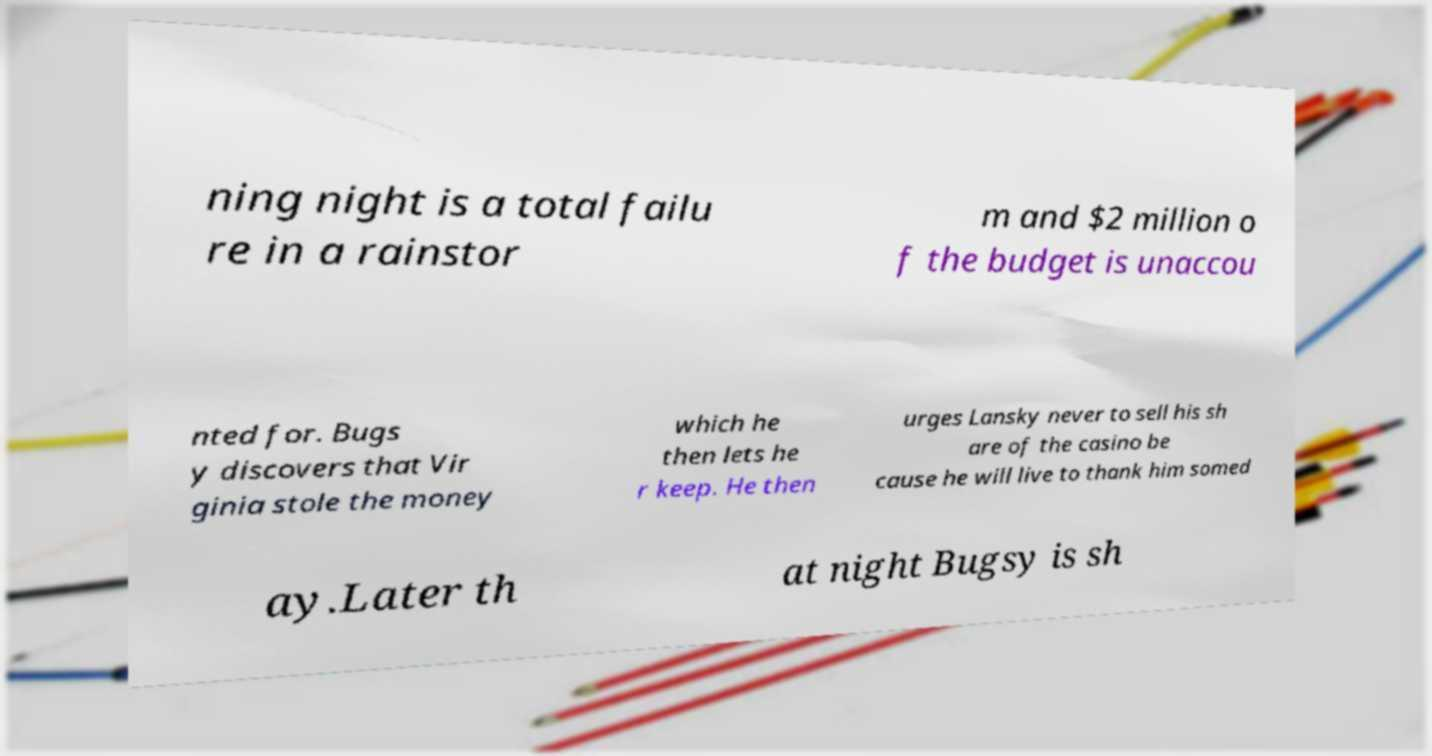Please read and relay the text visible in this image. What does it say? ning night is a total failu re in a rainstor m and $2 million o f the budget is unaccou nted for. Bugs y discovers that Vir ginia stole the money which he then lets he r keep. He then urges Lansky never to sell his sh are of the casino be cause he will live to thank him somed ay.Later th at night Bugsy is sh 